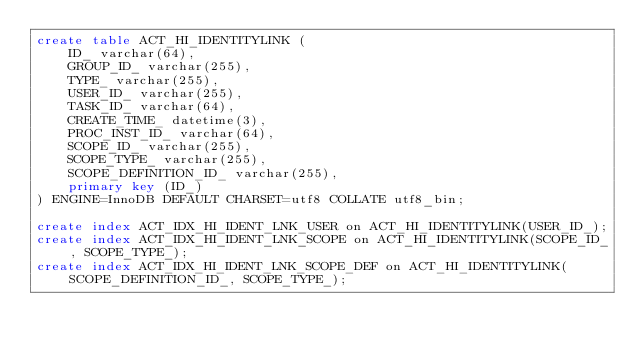<code> <loc_0><loc_0><loc_500><loc_500><_SQL_>create table ACT_HI_IDENTITYLINK (
    ID_ varchar(64),
    GROUP_ID_ varchar(255),
    TYPE_ varchar(255),
    USER_ID_ varchar(255),
    TASK_ID_ varchar(64),
    CREATE_TIME_ datetime(3),
    PROC_INST_ID_ varchar(64),
    SCOPE_ID_ varchar(255),
    SCOPE_TYPE_ varchar(255),
    SCOPE_DEFINITION_ID_ varchar(255),
    primary key (ID_)
) ENGINE=InnoDB DEFAULT CHARSET=utf8 COLLATE utf8_bin;

create index ACT_IDX_HI_IDENT_LNK_USER on ACT_HI_IDENTITYLINK(USER_ID_);
create index ACT_IDX_HI_IDENT_LNK_SCOPE on ACT_HI_IDENTITYLINK(SCOPE_ID_, SCOPE_TYPE_);
create index ACT_IDX_HI_IDENT_LNK_SCOPE_DEF on ACT_HI_IDENTITYLINK(SCOPE_DEFINITION_ID_, SCOPE_TYPE_);
</code> 